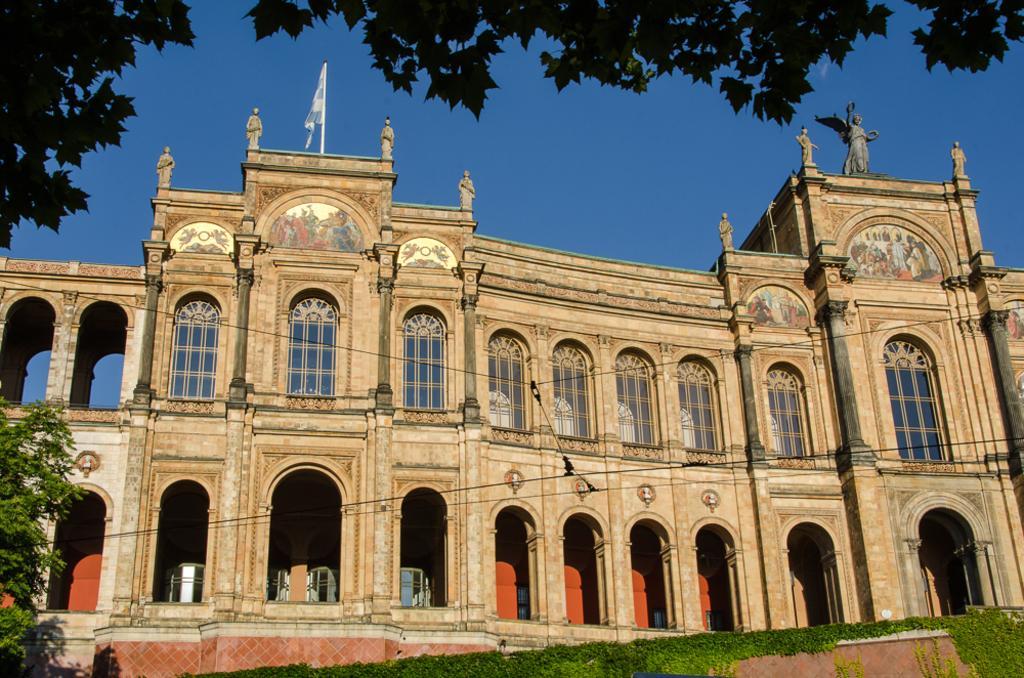Describe this image in one or two sentences. In this picture, we can see a building with windows, doors, flag, statue, trees, ground with grass, and the sky. 